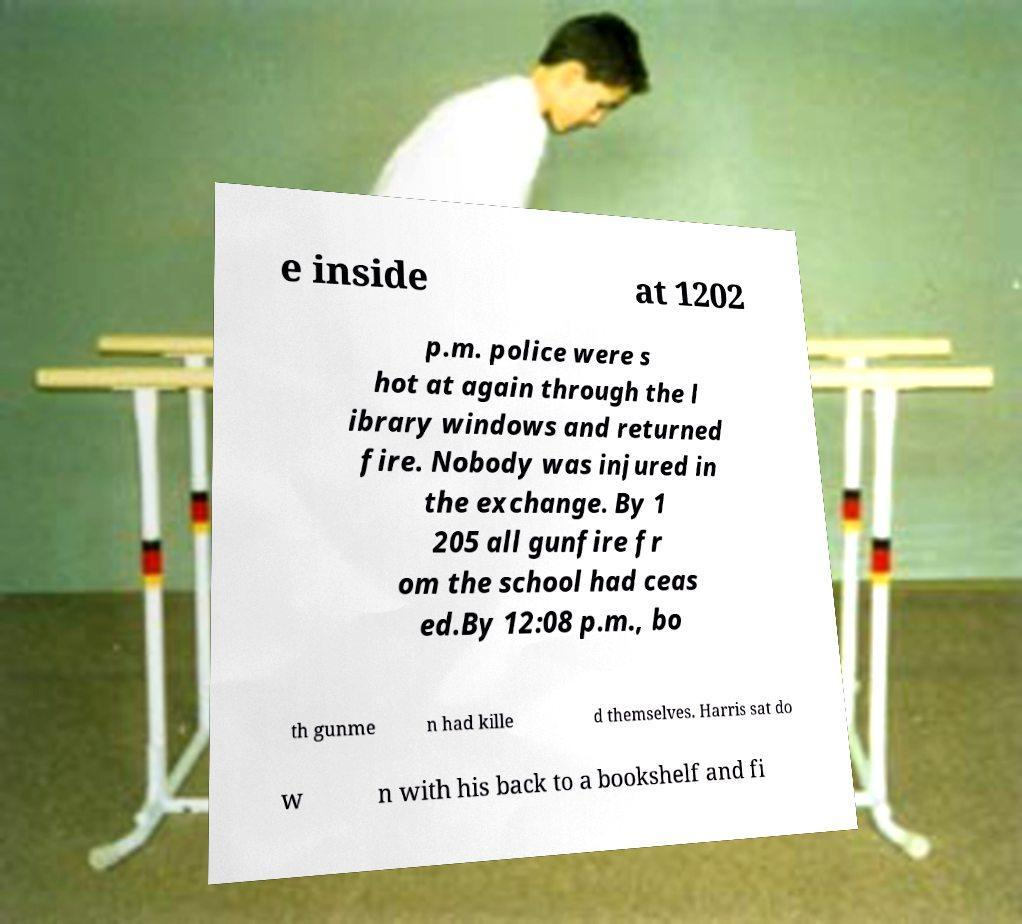For documentation purposes, I need the text within this image transcribed. Could you provide that? e inside at 1202 p.m. police were s hot at again through the l ibrary windows and returned fire. Nobody was injured in the exchange. By 1 205 all gunfire fr om the school had ceas ed.By 12:08 p.m., bo th gunme n had kille d themselves. Harris sat do w n with his back to a bookshelf and fi 